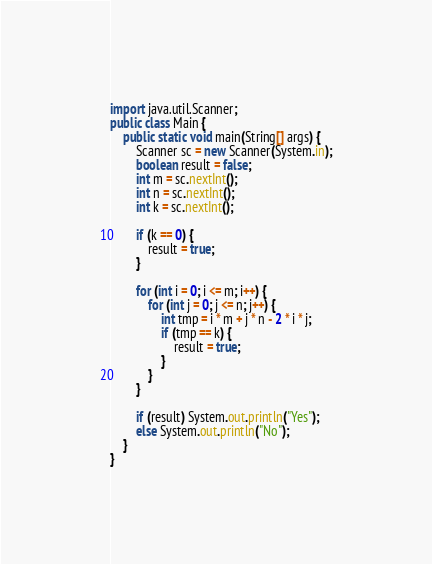<code> <loc_0><loc_0><loc_500><loc_500><_Java_>import java.util.Scanner;
public class Main {
	public static void main(String[] args) {
		Scanner sc = new Scanner(System.in);
		boolean result = false;
		int m = sc.nextInt();
		int n = sc.nextInt();
		int k = sc.nextInt();

		if (k == 0) {
			result = true;
		}

		for (int i = 0; i <= m; i++) {
			for (int j = 0; j <= n; j++) {
				int tmp = i * m + j * n - 2 * i * j;
				if (tmp == k) {
					result = true;
				}
			}
		}

		if (result) System.out.println("Yes");
		else System.out.println("No");
	}
}</code> 